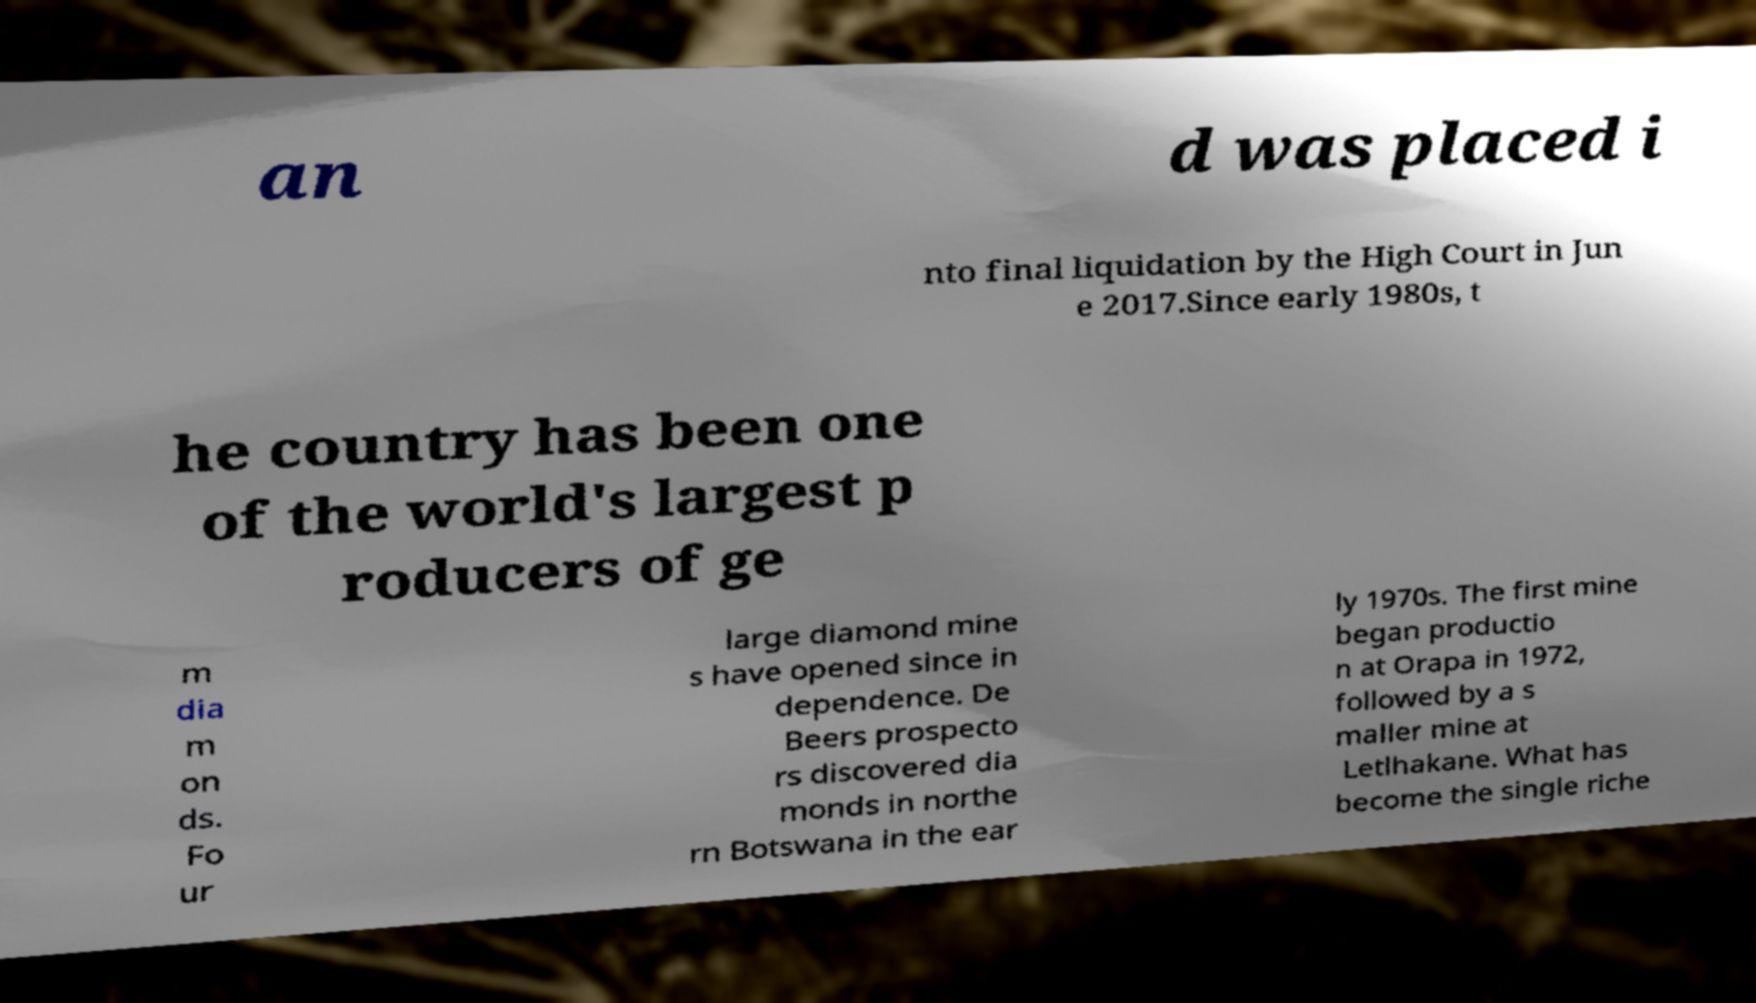Please identify and transcribe the text found in this image. an d was placed i nto final liquidation by the High Court in Jun e 2017.Since early 1980s, t he country has been one of the world's largest p roducers of ge m dia m on ds. Fo ur large diamond mine s have opened since in dependence. De Beers prospecto rs discovered dia monds in northe rn Botswana in the ear ly 1970s. The first mine began productio n at Orapa in 1972, followed by a s maller mine at Letlhakane. What has become the single riche 